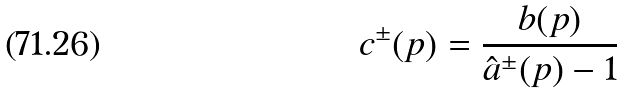<formula> <loc_0><loc_0><loc_500><loc_500>c ^ { \pm } ( p ) = \frac { b ( p ) } { \hat { a } ^ { \pm } ( p ) - 1 }</formula> 